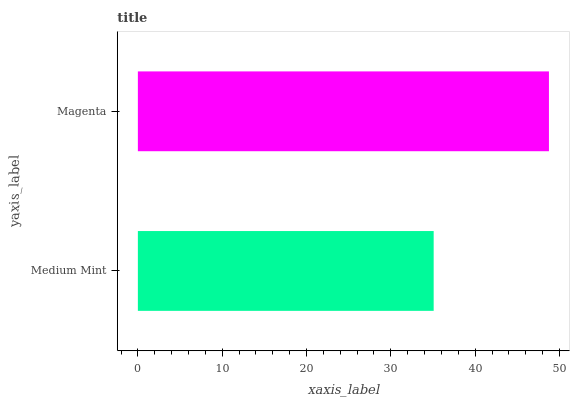Is Medium Mint the minimum?
Answer yes or no. Yes. Is Magenta the maximum?
Answer yes or no. Yes. Is Magenta the minimum?
Answer yes or no. No. Is Magenta greater than Medium Mint?
Answer yes or no. Yes. Is Medium Mint less than Magenta?
Answer yes or no. Yes. Is Medium Mint greater than Magenta?
Answer yes or no. No. Is Magenta less than Medium Mint?
Answer yes or no. No. Is Magenta the high median?
Answer yes or no. Yes. Is Medium Mint the low median?
Answer yes or no. Yes. Is Medium Mint the high median?
Answer yes or no. No. Is Magenta the low median?
Answer yes or no. No. 